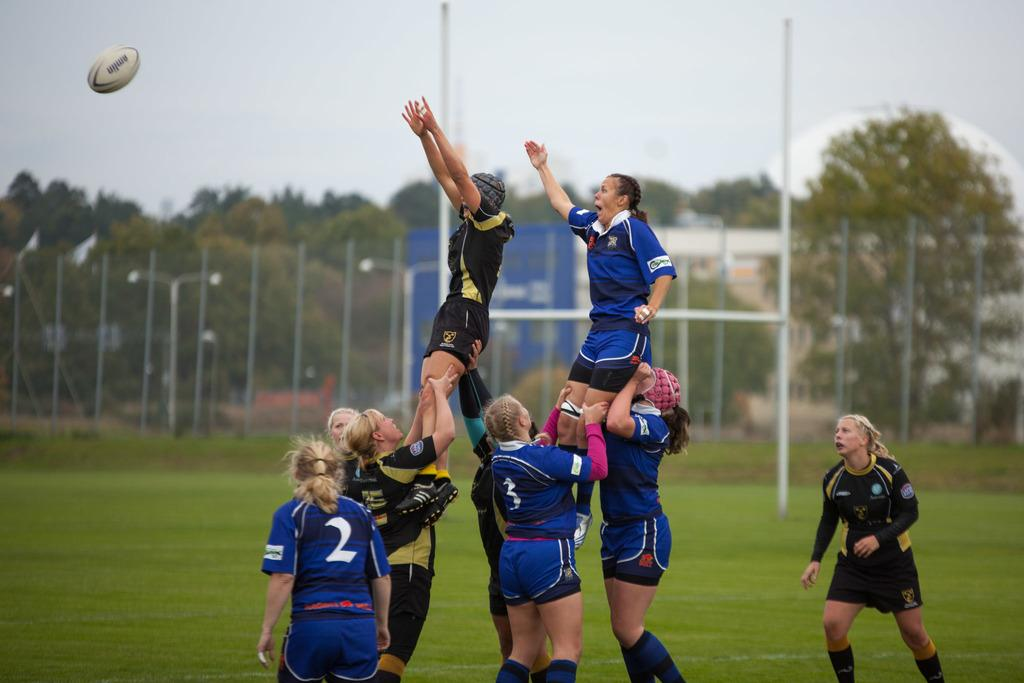<image>
Relay a brief, clear account of the picture shown. A group of girls in jerseys one jersey has a two on the back. 